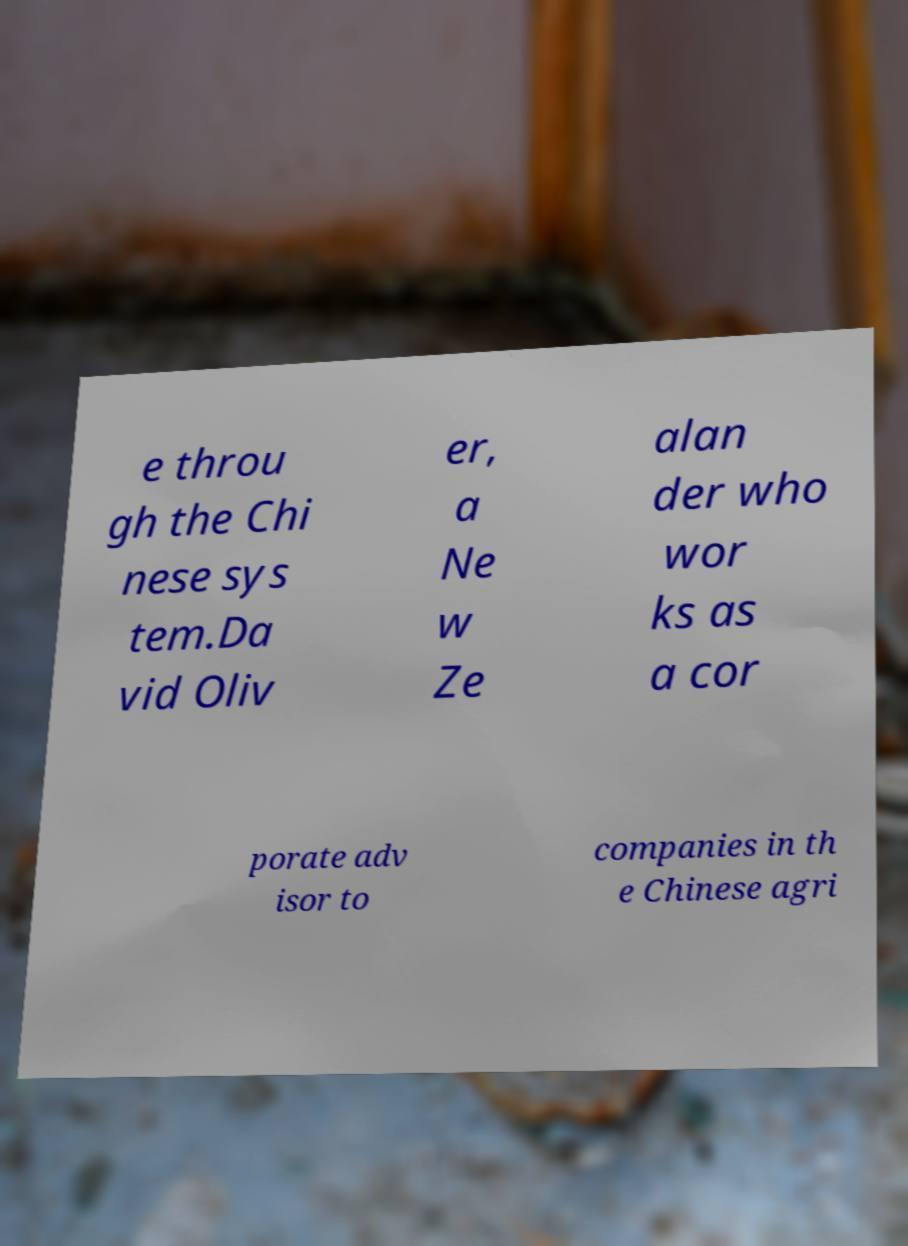Please identify and transcribe the text found in this image. e throu gh the Chi nese sys tem.Da vid Oliv er, a Ne w Ze alan der who wor ks as a cor porate adv isor to companies in th e Chinese agri 